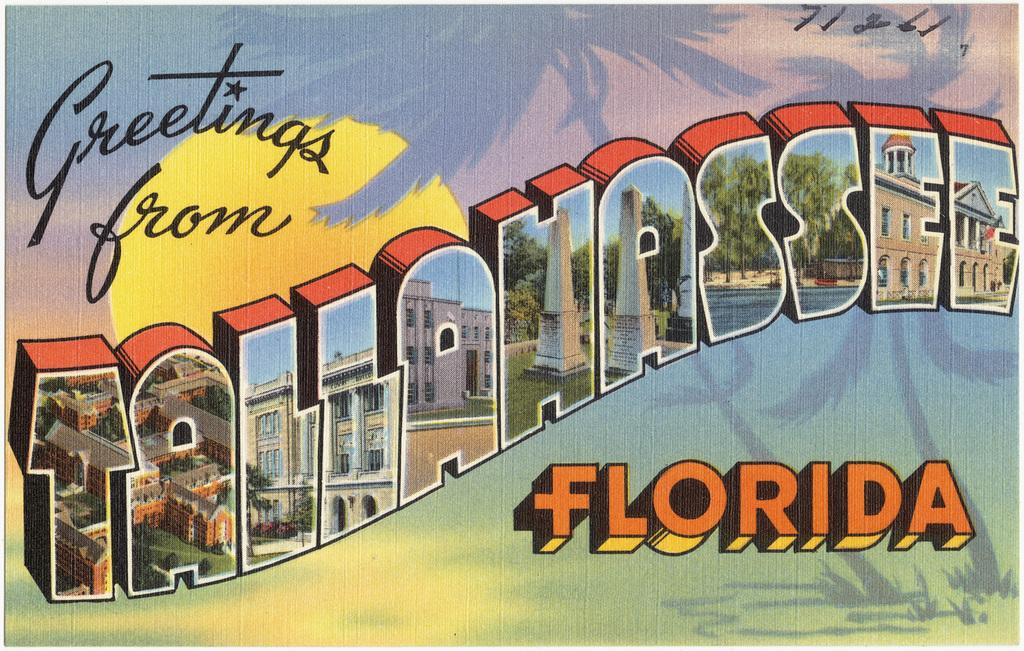<image>
Create a compact narrative representing the image presented. a postcard that says 'greetings from tallahassee florida' 